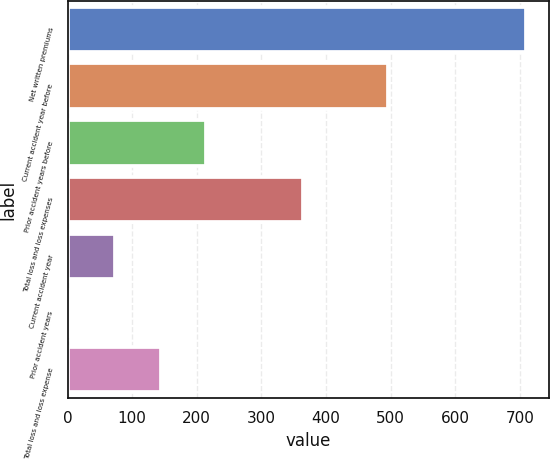Convert chart to OTSL. <chart><loc_0><loc_0><loc_500><loc_500><bar_chart><fcel>Net written premiums<fcel>Current accident year before<fcel>Prior accident years before<fcel>Total loss and loss expenses<fcel>Current accident year<fcel>Prior accident years<fcel>Total loss and loss expense<nl><fcel>710<fcel>496<fcel>214.64<fcel>364<fcel>73.12<fcel>2.36<fcel>143.88<nl></chart> 